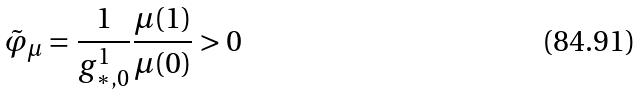<formula> <loc_0><loc_0><loc_500><loc_500>\tilde { \varphi } _ { \mu } = \frac { 1 } { g _ { * , 0 } ^ { 1 } } \frac { \mu ( 1 ) } { \mu ( 0 ) } > 0</formula> 